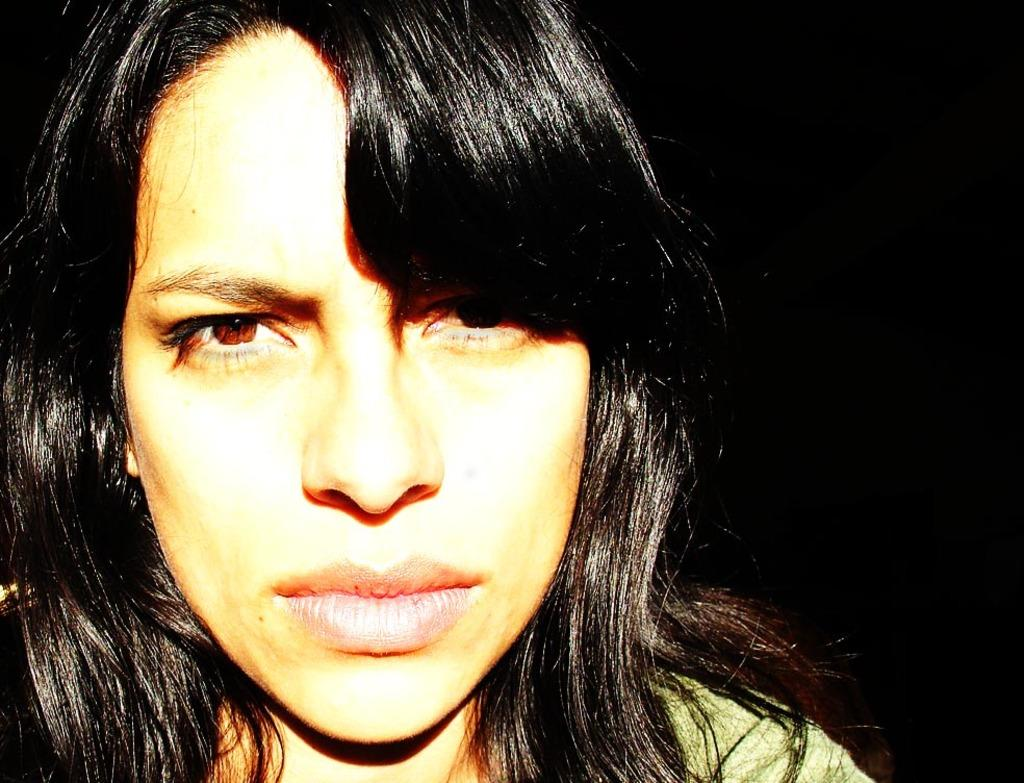What is the main subject of the image? There is a lady in the image. Can you describe the lady's hair color? The lady's hair is black in color. What type of bird can be seen singing in the image? There is no bird present in the image, and therefore no singing can be observed. 